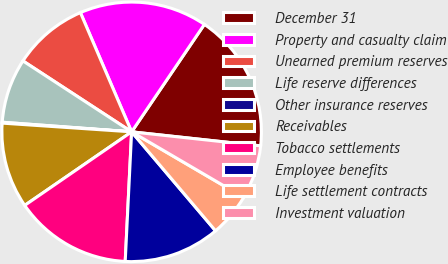<chart> <loc_0><loc_0><loc_500><loc_500><pie_chart><fcel>December 31<fcel>Property and casualty claim<fcel>Unearned premium reserves<fcel>Life reserve differences<fcel>Other insurance reserves<fcel>Receivables<fcel>Tobacco settlements<fcel>Employee benefits<fcel>Life settlement contracts<fcel>Investment valuation<nl><fcel>17.25%<fcel>15.93%<fcel>9.34%<fcel>8.02%<fcel>0.11%<fcel>10.66%<fcel>14.62%<fcel>11.98%<fcel>5.38%<fcel>6.7%<nl></chart> 